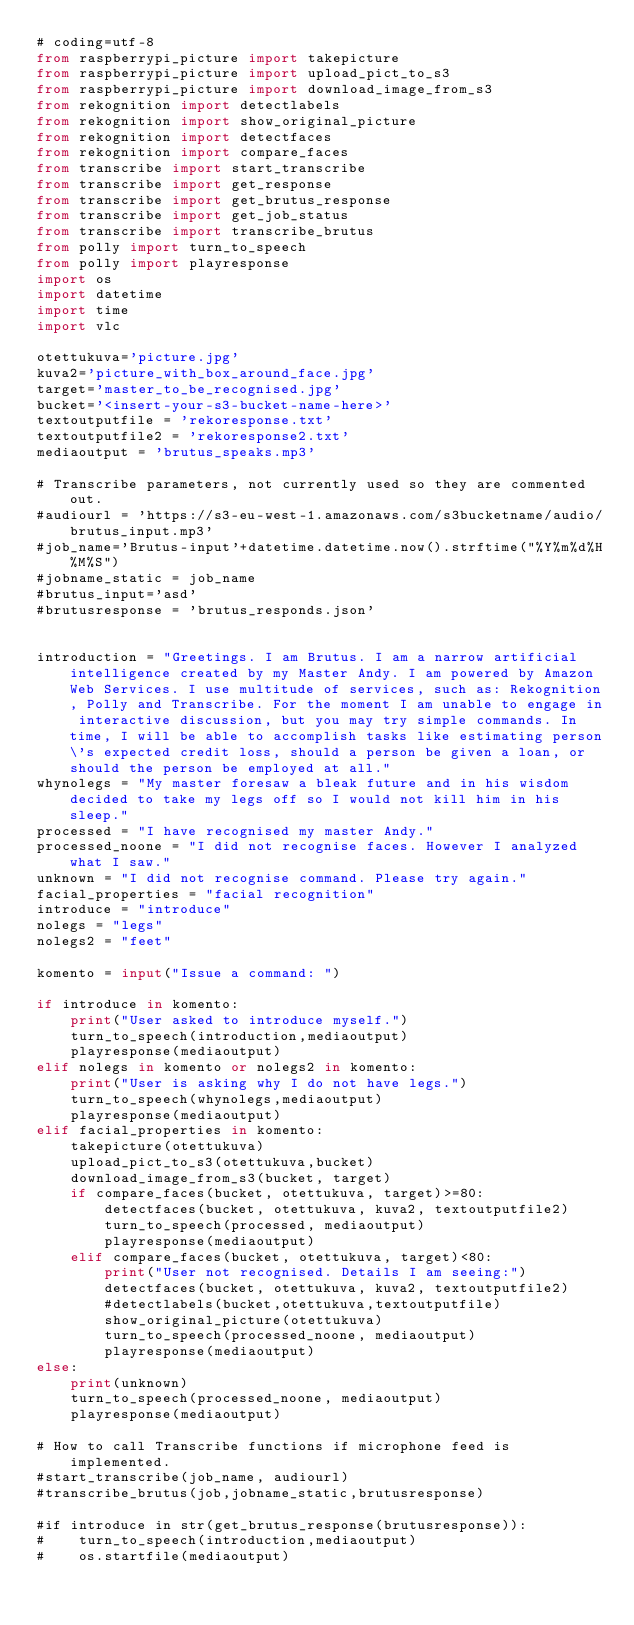<code> <loc_0><loc_0><loc_500><loc_500><_Python_># coding=utf-8
from raspberrypi_picture import takepicture
from raspberrypi_picture import upload_pict_to_s3
from raspberrypi_picture import download_image_from_s3
from rekognition import detectlabels
from rekognition import show_original_picture
from rekognition import detectfaces
from rekognition import compare_faces
from transcribe import start_transcribe
from transcribe import get_response
from transcribe import get_brutus_response
from transcribe import get_job_status
from transcribe import transcribe_brutus
from polly import turn_to_speech
from polly import playresponse
import os
import datetime
import time
import vlc

otettukuva='picture.jpg'
kuva2='picture_with_box_around_face.jpg'
target='master_to_be_recognised.jpg'
bucket='<insert-your-s3-bucket-name-here>'
textoutputfile = 'rekoresponse.txt'
textoutputfile2 = 'rekoresponse2.txt'
mediaoutput = 'brutus_speaks.mp3'

# Transcribe parameters, not currently used so they are commented out.
#audiourl = 'https://s3-eu-west-1.amazonaws.com/s3bucketname/audio/brutus_input.mp3'
#job_name='Brutus-input'+datetime.datetime.now().strftime("%Y%m%d%H%M%S")
#jobname_static = job_name
#brutus_input='asd'
#brutusresponse = 'brutus_responds.json'


introduction = "Greetings. I am Brutus. I am a narrow artificial intelligence created by my Master Andy. I am powered by Amazon Web Services. I use multitude of services, such as: Rekognition, Polly and Transcribe. For the moment I am unable to engage in interactive discussion, but you may try simple commands. In time, I will be able to accomplish tasks like estimating person\'s expected credit loss, should a person be given a loan, or should the person be employed at all."
whynolegs = "My master foresaw a bleak future and in his wisdom decided to take my legs off so I would not kill him in his sleep."
processed = "I have recognised my master Andy."
processed_noone = "I did not recognise faces. However I analyzed what I saw."
unknown = "I did not recognise command. Please try again."
facial_properties = "facial recognition"
introduce = "introduce"
nolegs = "legs"
nolegs2 = "feet"

komento = input("Issue a command: ")

if introduce in komento:
    print("User asked to introduce myself.")
    turn_to_speech(introduction,mediaoutput)
    playresponse(mediaoutput)
elif nolegs in komento or nolegs2 in komento:
    print("User is asking why I do not have legs.")
    turn_to_speech(whynolegs,mediaoutput)
    playresponse(mediaoutput)
elif facial_properties in komento:
    takepicture(otettukuva)
    upload_pict_to_s3(otettukuva,bucket)
    download_image_from_s3(bucket, target)
    if compare_faces(bucket, otettukuva, target)>=80:
        detectfaces(bucket, otettukuva, kuva2, textoutputfile2)
        turn_to_speech(processed, mediaoutput)
        playresponse(mediaoutput)
    elif compare_faces(bucket, otettukuva, target)<80:
        print("User not recognised. Details I am seeing:")
        detectfaces(bucket, otettukuva, kuva2, textoutputfile2)
        #detectlabels(bucket,otettukuva,textoutputfile)
        show_original_picture(otettukuva)
        turn_to_speech(processed_noone, mediaoutput)
        playresponse(mediaoutput)
else:
    print(unknown)
    turn_to_speech(processed_noone, mediaoutput)
    playresponse(mediaoutput)

# How to call Transcribe functions if microphone feed is implemented.
#start_transcribe(job_name, audiourl)
#transcribe_brutus(job,jobname_static,brutusresponse)

#if introduce in str(get_brutus_response(brutusresponse)):
#    turn_to_speech(introduction,mediaoutput)
#    os.startfile(mediaoutput)
</code> 